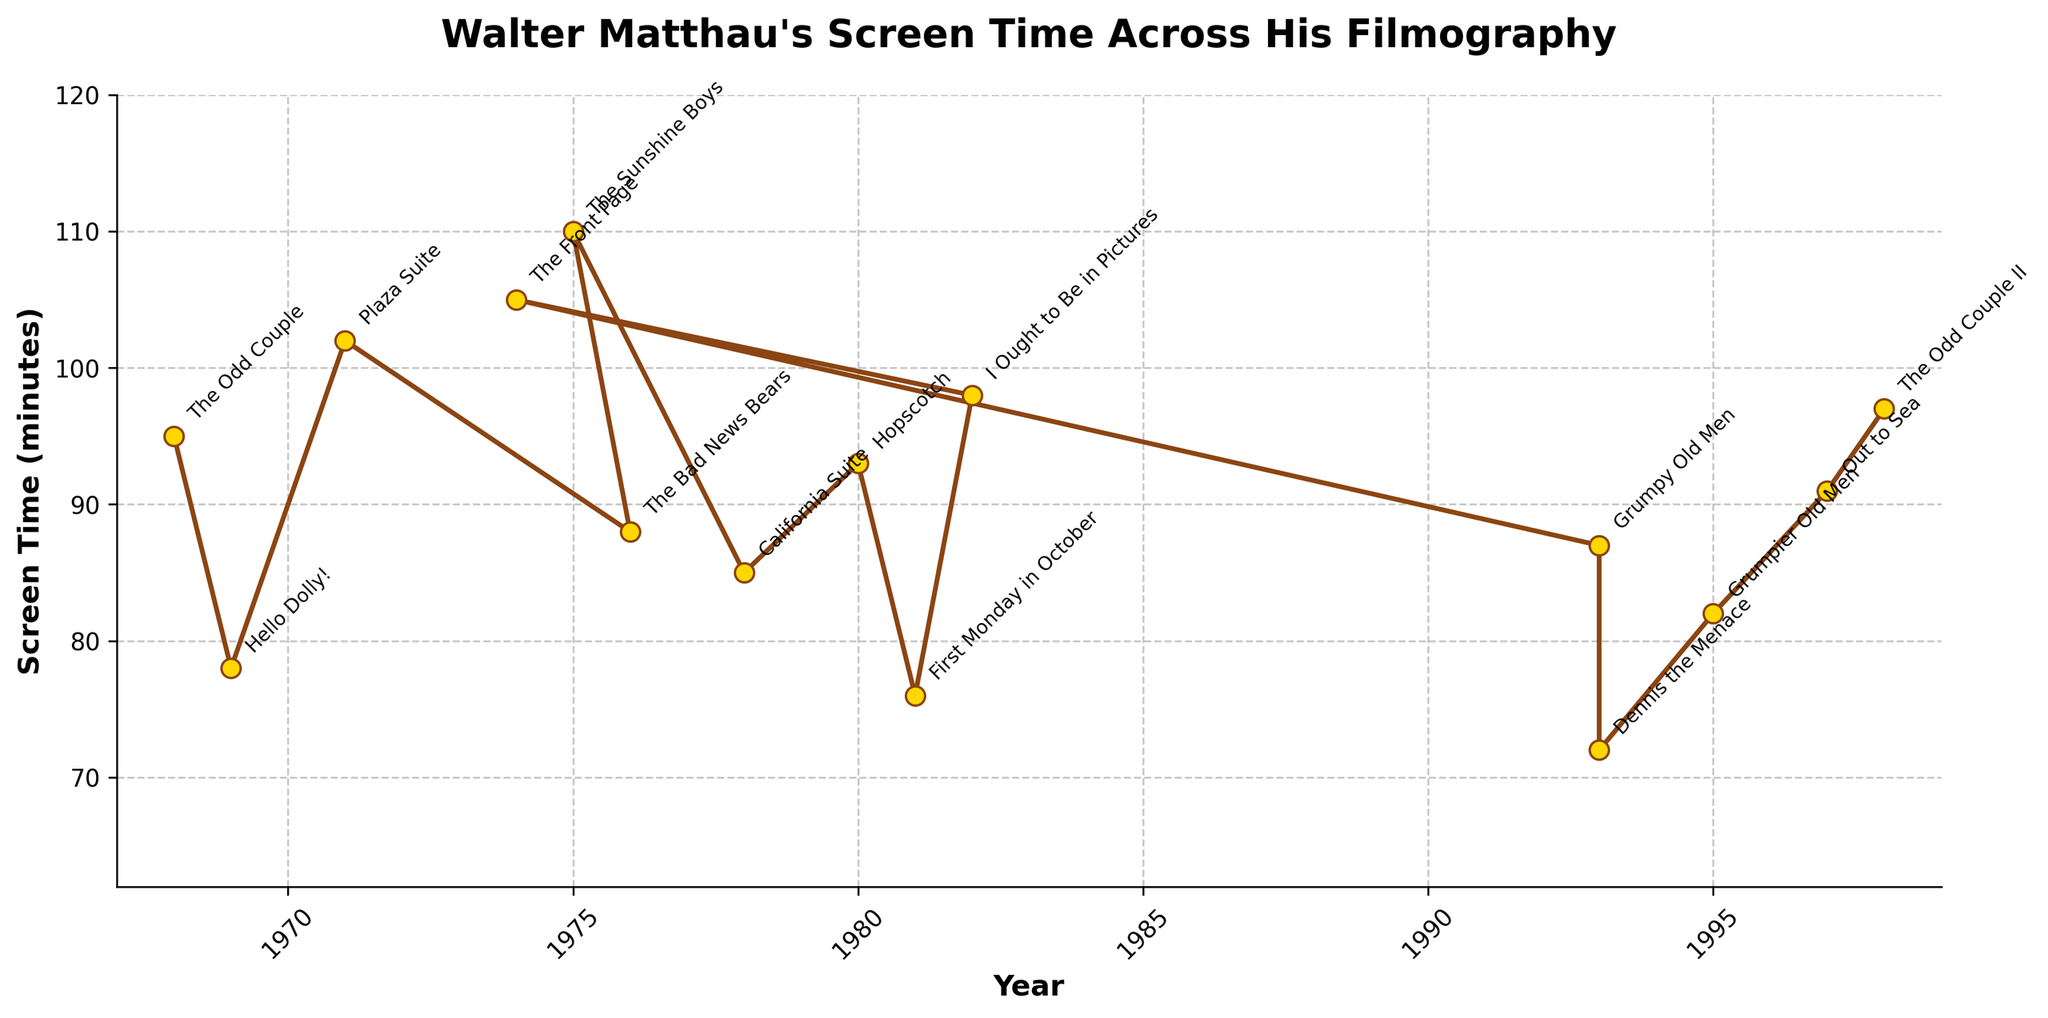What's the span of years covered by the movies in the plot? Examine the earliest and latest years on the x-axis. The earliest year is 1968 and the latest year is 1998. Subtracting the earliest year from the latest year gives us the time span. 1998 - 1968 = 30 years
Answer: 30 years Which movie has the highest screen time, and what is that screen time? Identify the peak point on the y-axis and then locate the corresponding movie annotation on the plot. The highest point corresponds to "The Sunshine Boys" with a screen time of 110 minutes
Answer: The Sunshine Boys, 110 minutes How does the screen time for "The Odd Couple II" compare to its predecessor "The Odd Couple"? Find the screen time values for both movies and compare them. "The Odd Couple II" has 97 minutes, and "The Odd Couple" has 95 minutes. So, "The Odd Couple II" has 2 minutes more screen time than "The Odd Couple"
Answer: "The Odd Couple II" has 2 minutes more screen time What is the average screen time across all the movies? Sum the screen times and divide by the number of movies. The total screen time is 1507 minutes and there are 15 movies. 1507/15 = 100.47
Answer: 100.47 minutes Which year marks Walter Matthau's lowest screen time in a movie, and what is that screen time? Identify the lowest point on the y-axis and then locate the corresponding year on the plot. The lowest point corresponds to "Dennis the Menace" in 1993 with a screen time of 72 minutes
Answer: 1993, 72 minutes Is there a trend in screen time over the years? If so, what is it? Analyze the overall direction of the data points across the years. Although there are fluctuations, there doesn't appear to be a clear upward or downward trend over the years. Instead, the screen time varies significantly from movie to movie
Answer: No clear trend Which movie released in the 1970s has the highest screen time and what is it? Focus on the data points in the 1970s and identify the highest point. "The Sunshine Boys" in 1975 has the highest screen time with 110 minutes
Answer: The Sunshine Boys, 110 minutes How many movies have a screen time above 90 minutes? Count the number of movies above the 90-minute mark on the y-axis. "The Odd Couple", "Plaza Suite", "Hopscotch", "I Ought to Be in Pictures", "The Front Page", "Out to Sea", and "The Odd Couple II" all exceed 90 minutes. That makes 7 movies in total
Answer: 7 movies Between "Hello Dolly!" and "California Suite", which has a longer screen time and by how much? Compare the screen time values for both movies. "Hello Dolly!" has 78 minutes and "California Suite" has 85 minutes. The difference is 85 - 78 = 7 minutes
Answer: California Suite has 7 minutes more What's the difference in screen time between the movie with the maximum screen time and the one with the minimum screen time? Identify the maximum and minimum screen times from the plot. Maximum is 110 minutes ("The Sunshine Boys") and minimum is 72 minutes ("Dennis the Menace"). The difference is 110 - 72 = 38 minutes
Answer: 38 minutes 